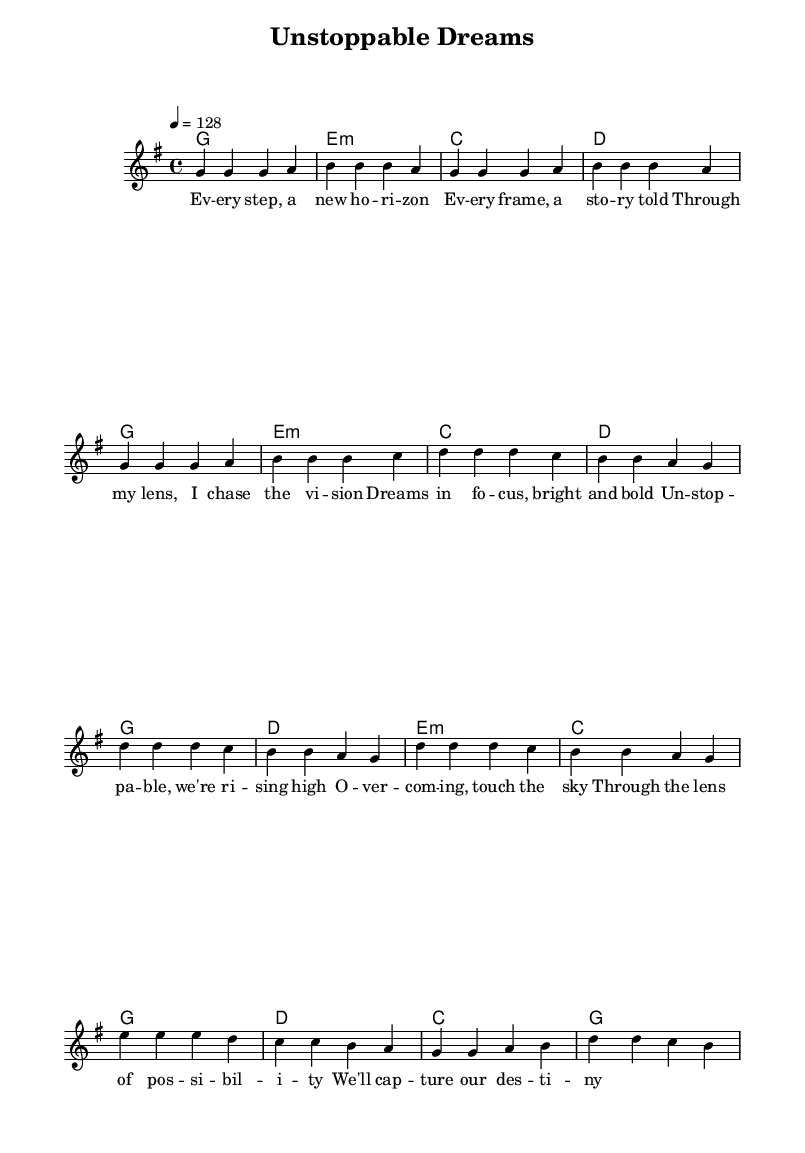What is the key signature of this music? The key signature is G major, which has one sharp (F#).
Answer: G major What is the time signature of this piece? The time signature is 4/4, which means there are four beats in each measure.
Answer: 4/4 What is the tempo marking of the piece? The tempo marking is 128 beats per minute, indicated in the score.
Answer: 128 How many measures are in the chorus? The chorus consists of 8 measures, as indicated by the layout of the notes and chords.
Answer: 8 What chord is played in the first measure of the verse? The first measure of the verse has a G major chord, clearly noted in the chord symbols above the staff.
Answer: G Explain the relationship between the melody and chords in the chorus. The melody notes in the chorus correspond with the given chords; for example, the first melody note "d'" aligns with the G chord, and the subsequent notes match with melodies progressing through D major, E minor, and C major chords respectively. This structure creates harmonic support.
Answer: Chords provide harmonic support to the melody 